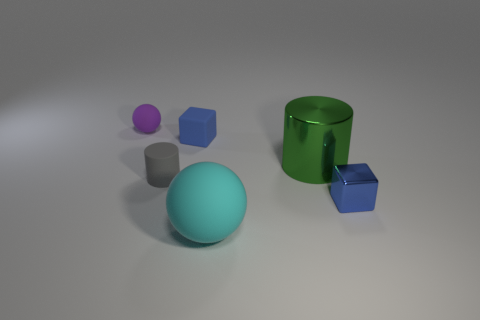Are there any shiny cylinders that have the same color as the big sphere?
Your answer should be very brief. No. Are there an equal number of tiny purple objects that are left of the small blue metallic block and big cyan spheres?
Offer a very short reply. Yes. Does the rubber cylinder have the same color as the metallic cylinder?
Keep it short and to the point. No. What is the size of the object that is both right of the cyan matte sphere and behind the small cylinder?
Give a very brief answer. Large. What color is the other sphere that is the same material as the purple ball?
Give a very brief answer. Cyan. How many large cyan objects have the same material as the gray thing?
Ensure brevity in your answer.  1. Is the number of shiny cubes that are in front of the cyan rubber sphere the same as the number of small purple things right of the tiny purple rubber object?
Offer a terse response. Yes. There is a cyan thing; is its shape the same as the small rubber thing behind the blue rubber thing?
Give a very brief answer. Yes. There is a small thing that is the same color as the tiny shiny cube; what material is it?
Your answer should be very brief. Rubber. Are there any other things that have the same shape as the big green metal object?
Your response must be concise. Yes. 